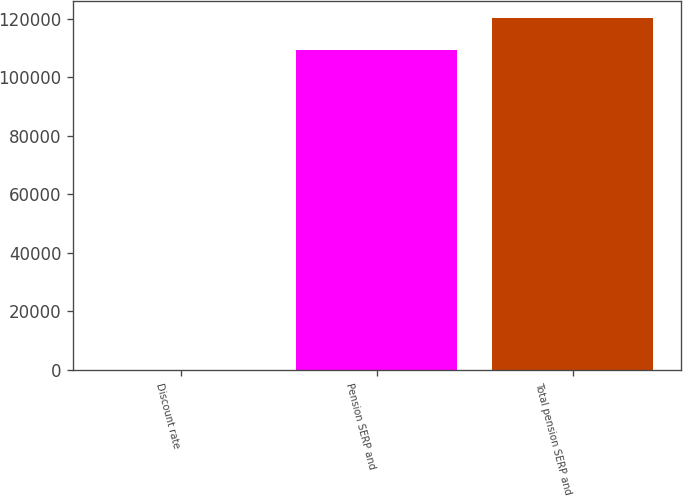Convert chart. <chart><loc_0><loc_0><loc_500><loc_500><bar_chart><fcel>Discount rate<fcel>Pension SERP and<fcel>Total pension SERP and<nl><fcel>5.49<fcel>109161<fcel>120143<nl></chart> 